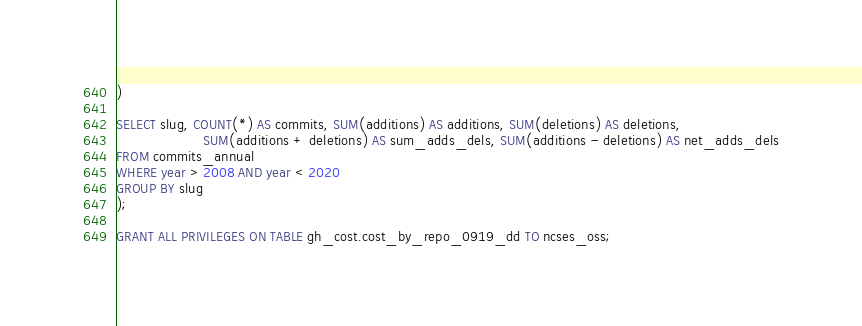Convert code to text. <code><loc_0><loc_0><loc_500><loc_500><_SQL_>)

SELECT slug, COUNT(*) AS commits, SUM(additions) AS additions, SUM(deletions) AS deletions,
					SUM(additions + deletions) AS sum_adds_dels, SUM(additions - deletions) AS net_adds_dels
FROM commits_annual
WHERE year > 2008 AND year < 2020
GROUP BY slug
);

GRANT ALL PRIVILEGES ON TABLE gh_cost.cost_by_repo_0919_dd TO ncses_oss;
</code> 